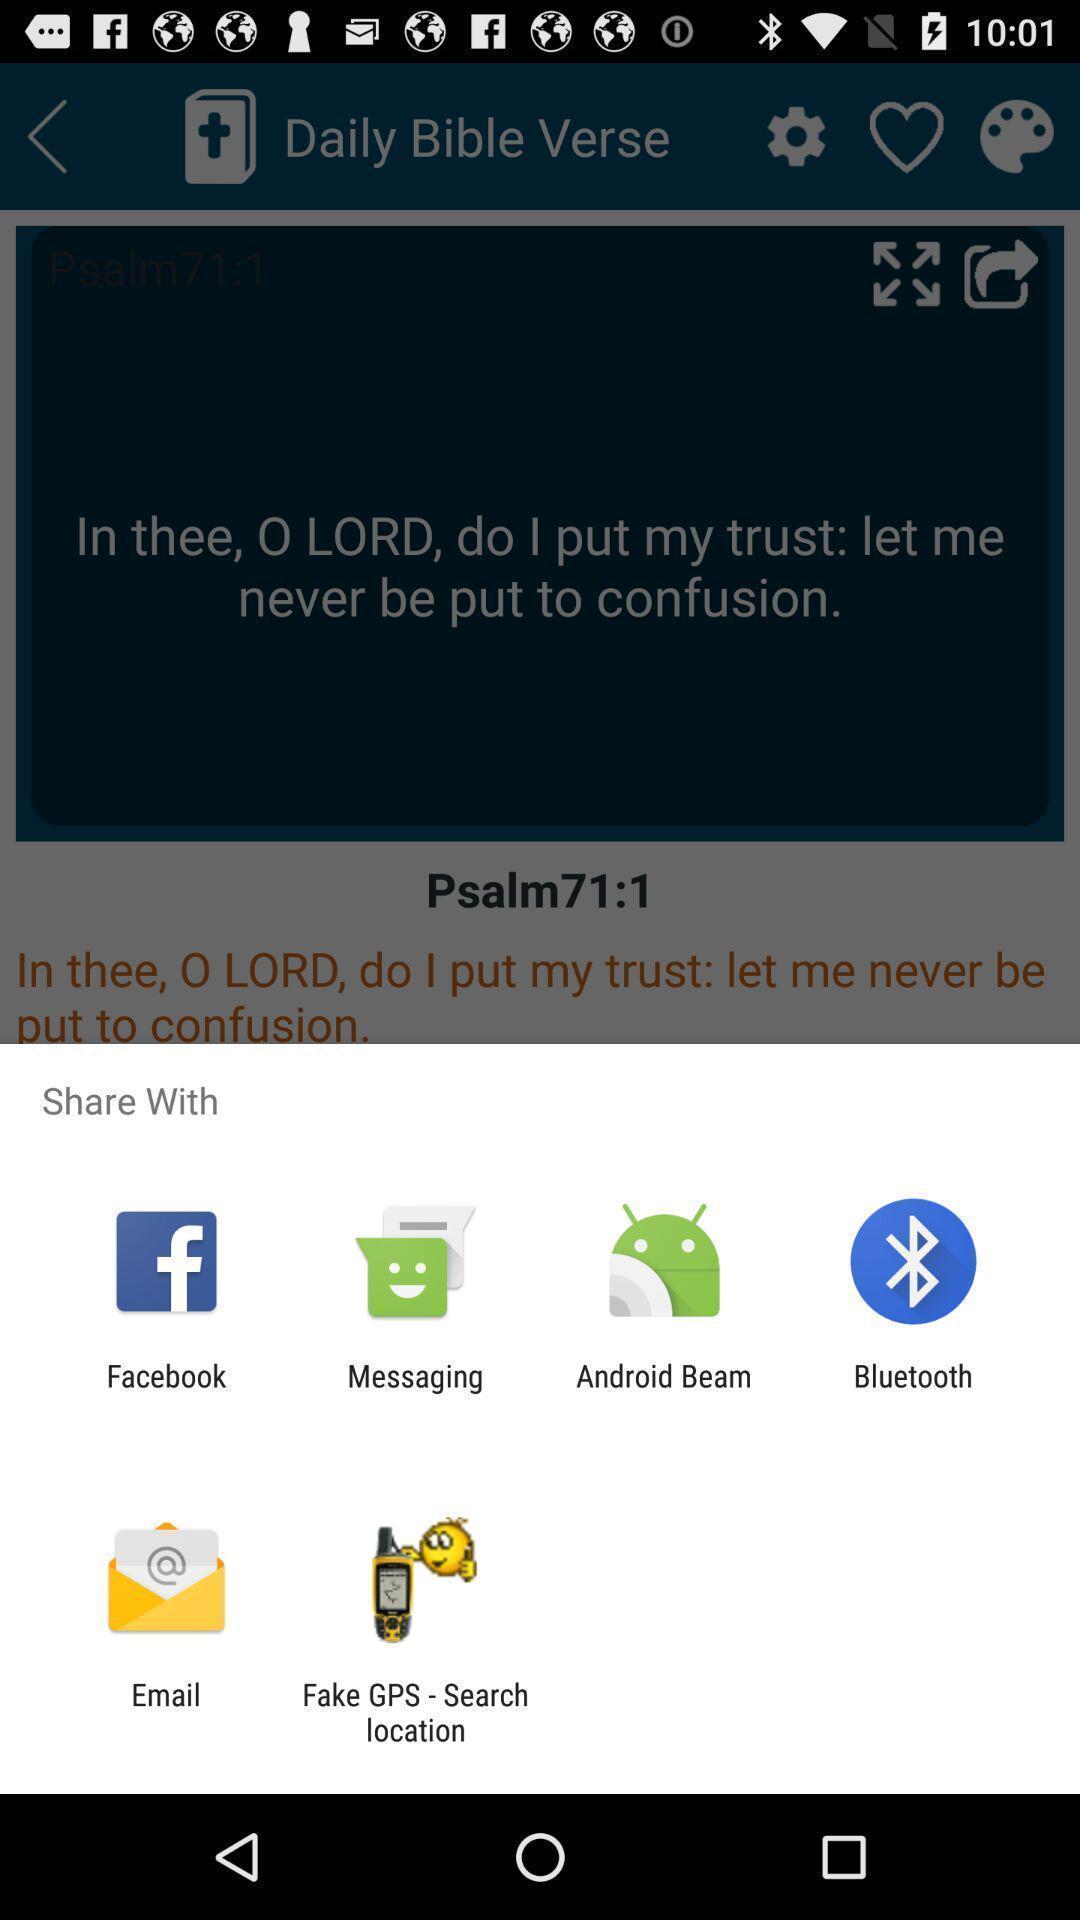What can you discern from this picture? Pop-up of various app icons. 